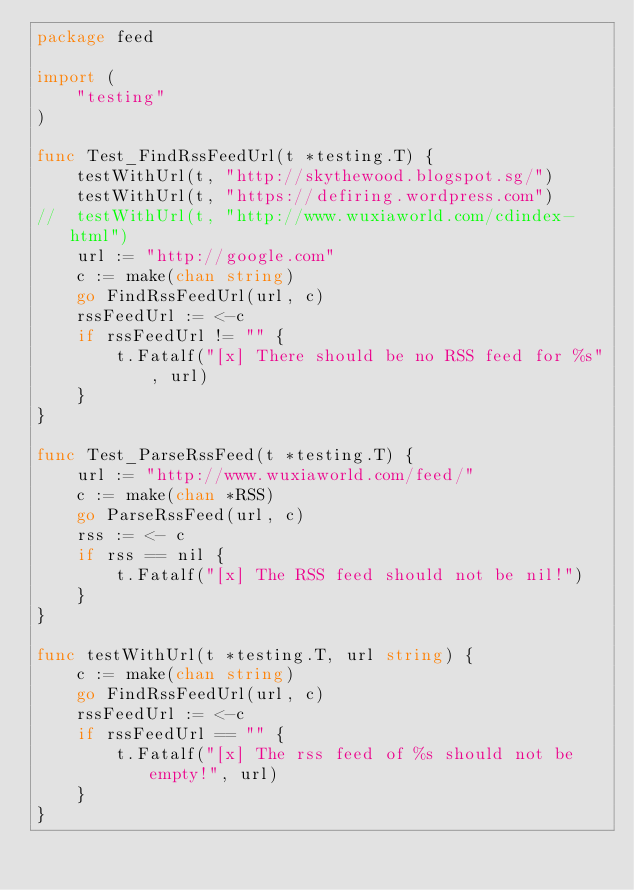Convert code to text. <code><loc_0><loc_0><loc_500><loc_500><_Go_>package feed

import (
	"testing"
)

func Test_FindRssFeedUrl(t *testing.T) {
	testWithUrl(t, "http://skythewood.blogspot.sg/")
	testWithUrl(t, "https://defiring.wordpress.com")
//	testWithUrl(t, "http://www.wuxiaworld.com/cdindex-html")
	url := "http://google.com"
	c := make(chan string)
	go FindRssFeedUrl(url, c)
	rssFeedUrl := <-c
	if rssFeedUrl != "" {
		t.Fatalf("[x] There should be no RSS feed for %s", url)
	}
}

func Test_ParseRssFeed(t *testing.T) {
	url := "http://www.wuxiaworld.com/feed/"
	c := make(chan *RSS)
	go ParseRssFeed(url, c)
	rss := <- c
	if rss == nil {
		t.Fatalf("[x] The RSS feed should not be nil!")
	}
}

func testWithUrl(t *testing.T, url string) {
	c := make(chan string)
	go FindRssFeedUrl(url, c)
	rssFeedUrl := <-c
	if rssFeedUrl == "" {
		t.Fatalf("[x] The rss feed of %s should not be empty!", url)
	}
}
</code> 